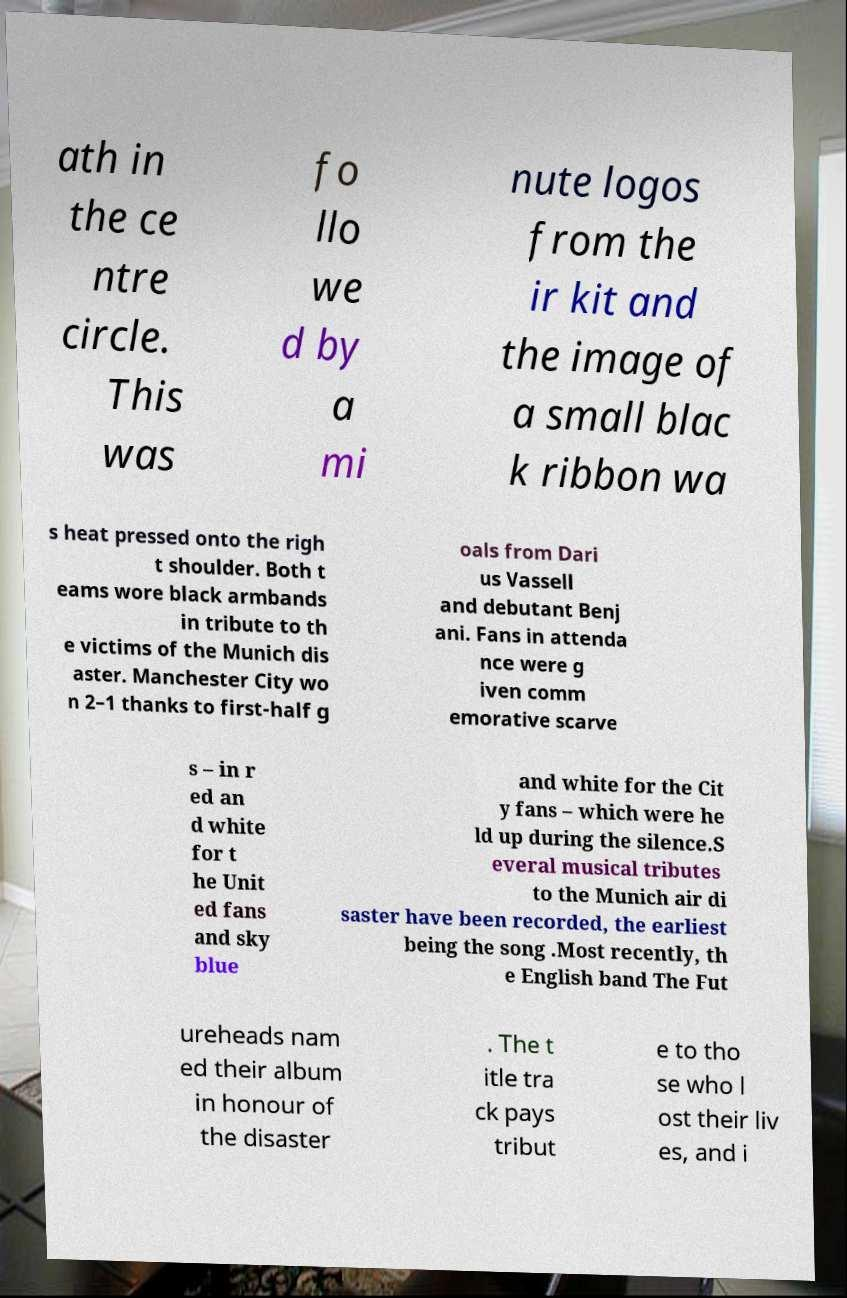Please identify and transcribe the text found in this image. ath in the ce ntre circle. This was fo llo we d by a mi nute logos from the ir kit and the image of a small blac k ribbon wa s heat pressed onto the righ t shoulder. Both t eams wore black armbands in tribute to th e victims of the Munich dis aster. Manchester City wo n 2–1 thanks to first-half g oals from Dari us Vassell and debutant Benj ani. Fans in attenda nce were g iven comm emorative scarve s – in r ed an d white for t he Unit ed fans and sky blue and white for the Cit y fans – which were he ld up during the silence.S everal musical tributes to the Munich air di saster have been recorded, the earliest being the song .Most recently, th e English band The Fut ureheads nam ed their album in honour of the disaster . The t itle tra ck pays tribut e to tho se who l ost their liv es, and i 